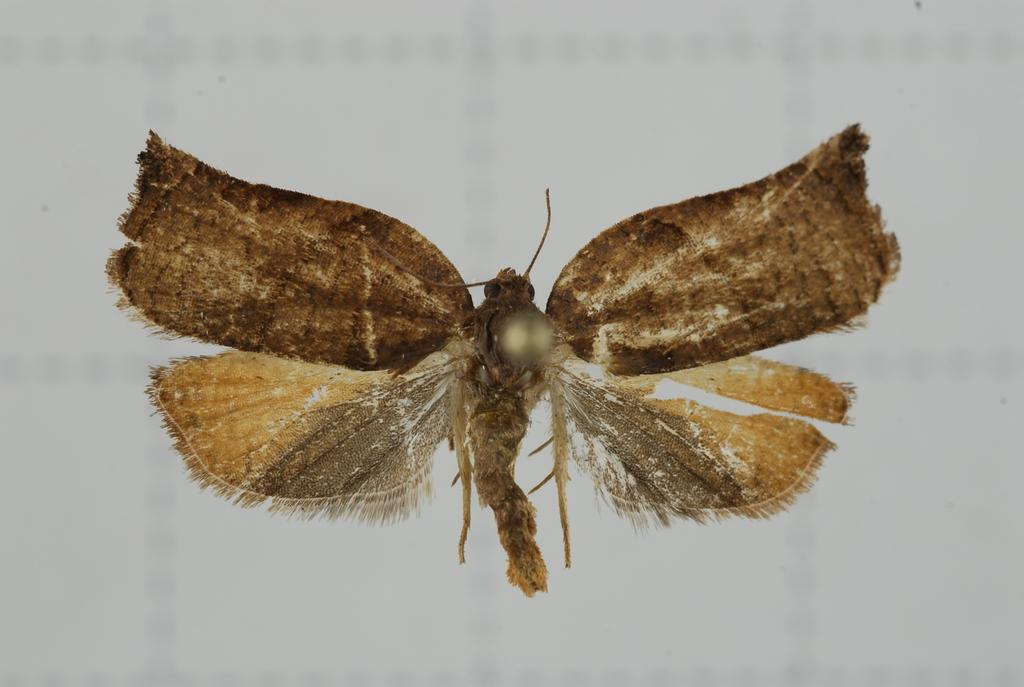What type of creature is present in the image? There is an insect with wings in the image. What can be observed about the background of the image? The background of the image appears to be white in color. How does the river affect the health of the insect in the image? There is no river present in the image, so it cannot affect the health of the insect. 